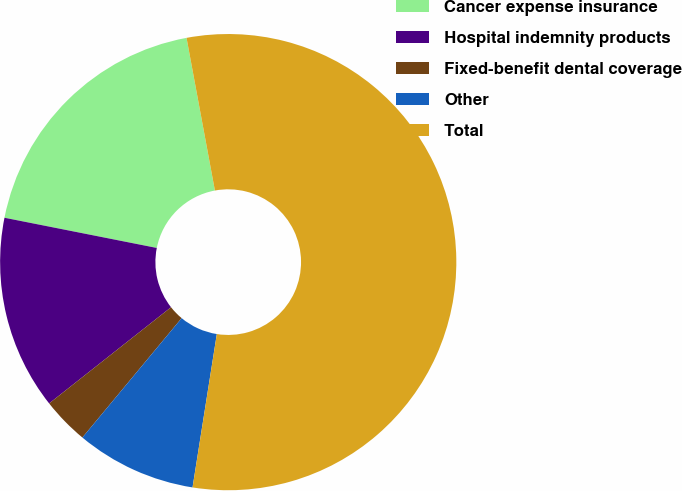Convert chart. <chart><loc_0><loc_0><loc_500><loc_500><pie_chart><fcel>Cancer expense insurance<fcel>Hospital indemnity products<fcel>Fixed-benefit dental coverage<fcel>Other<fcel>Total<nl><fcel>18.96%<fcel>13.75%<fcel>3.33%<fcel>8.54%<fcel>55.43%<nl></chart> 